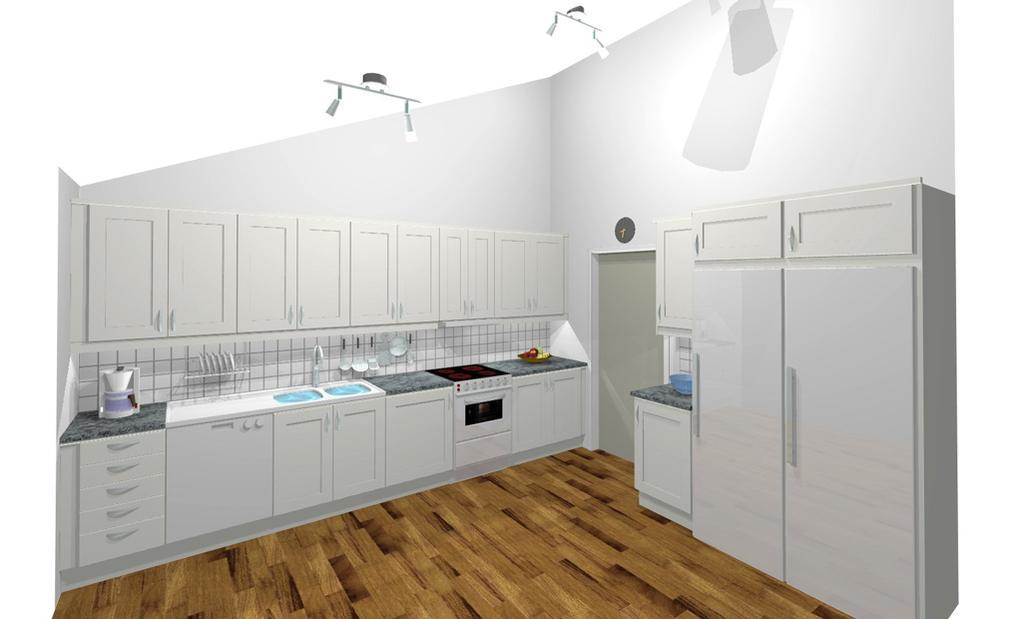Could you give a brief overview of what you see in this image? We can see floor and cupboards. We can see objects on shelf and we can see sink with tap and stove,under the stove we can see oven. Under the shelf we can see cupboards. We can see wall and cupboards. At the top we can see lights. 